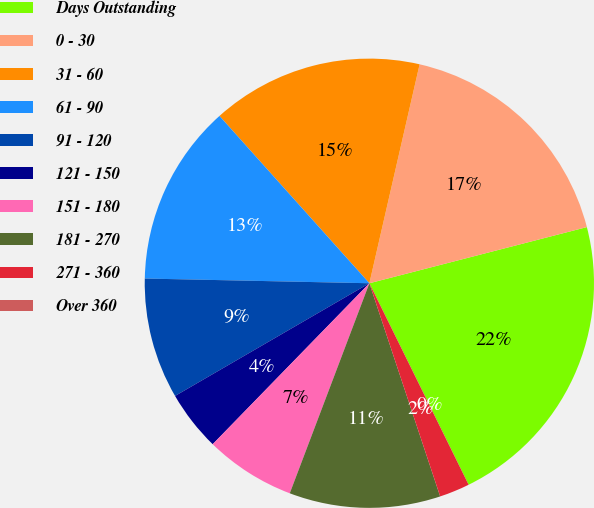Convert chart. <chart><loc_0><loc_0><loc_500><loc_500><pie_chart><fcel>Days Outstanding<fcel>0 - 30<fcel>31 - 60<fcel>61 - 90<fcel>91 - 120<fcel>121 - 150<fcel>151 - 180<fcel>181 - 270<fcel>271 - 360<fcel>Over 360<nl><fcel>21.74%<fcel>17.39%<fcel>15.22%<fcel>13.04%<fcel>8.7%<fcel>4.35%<fcel>6.52%<fcel>10.87%<fcel>2.18%<fcel>0.0%<nl></chart> 